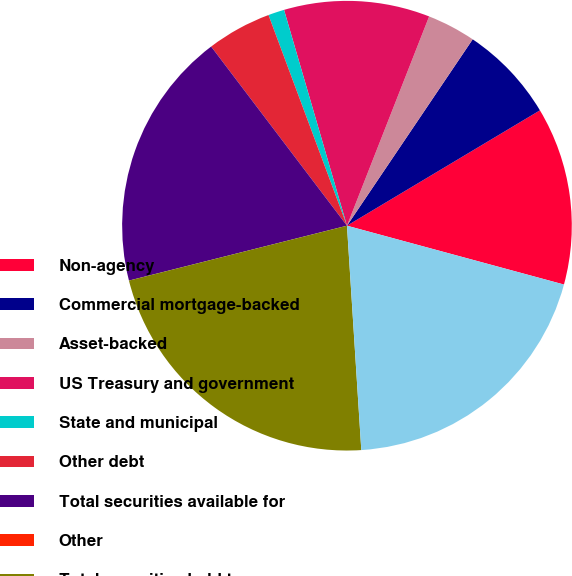Convert chart. <chart><loc_0><loc_0><loc_500><loc_500><pie_chart><fcel>Non-agency<fcel>Commercial mortgage-backed<fcel>Asset-backed<fcel>US Treasury and government<fcel>State and municipal<fcel>Other debt<fcel>Total securities available for<fcel>Other<fcel>Total securities held to<fcel>Commercial<nl><fcel>12.79%<fcel>6.98%<fcel>3.49%<fcel>10.47%<fcel>1.16%<fcel>4.65%<fcel>18.6%<fcel>0.0%<fcel>22.09%<fcel>19.77%<nl></chart> 